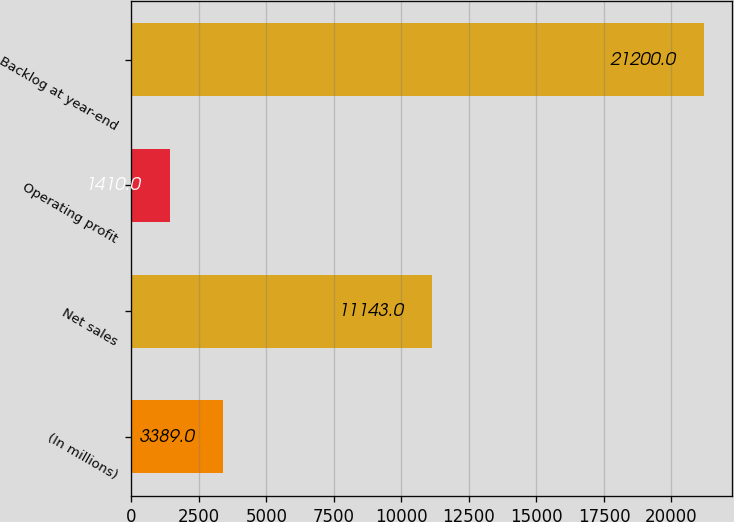<chart> <loc_0><loc_0><loc_500><loc_500><bar_chart><fcel>(In millions)<fcel>Net sales<fcel>Operating profit<fcel>Backlog at year-end<nl><fcel>3389<fcel>11143<fcel>1410<fcel>21200<nl></chart> 